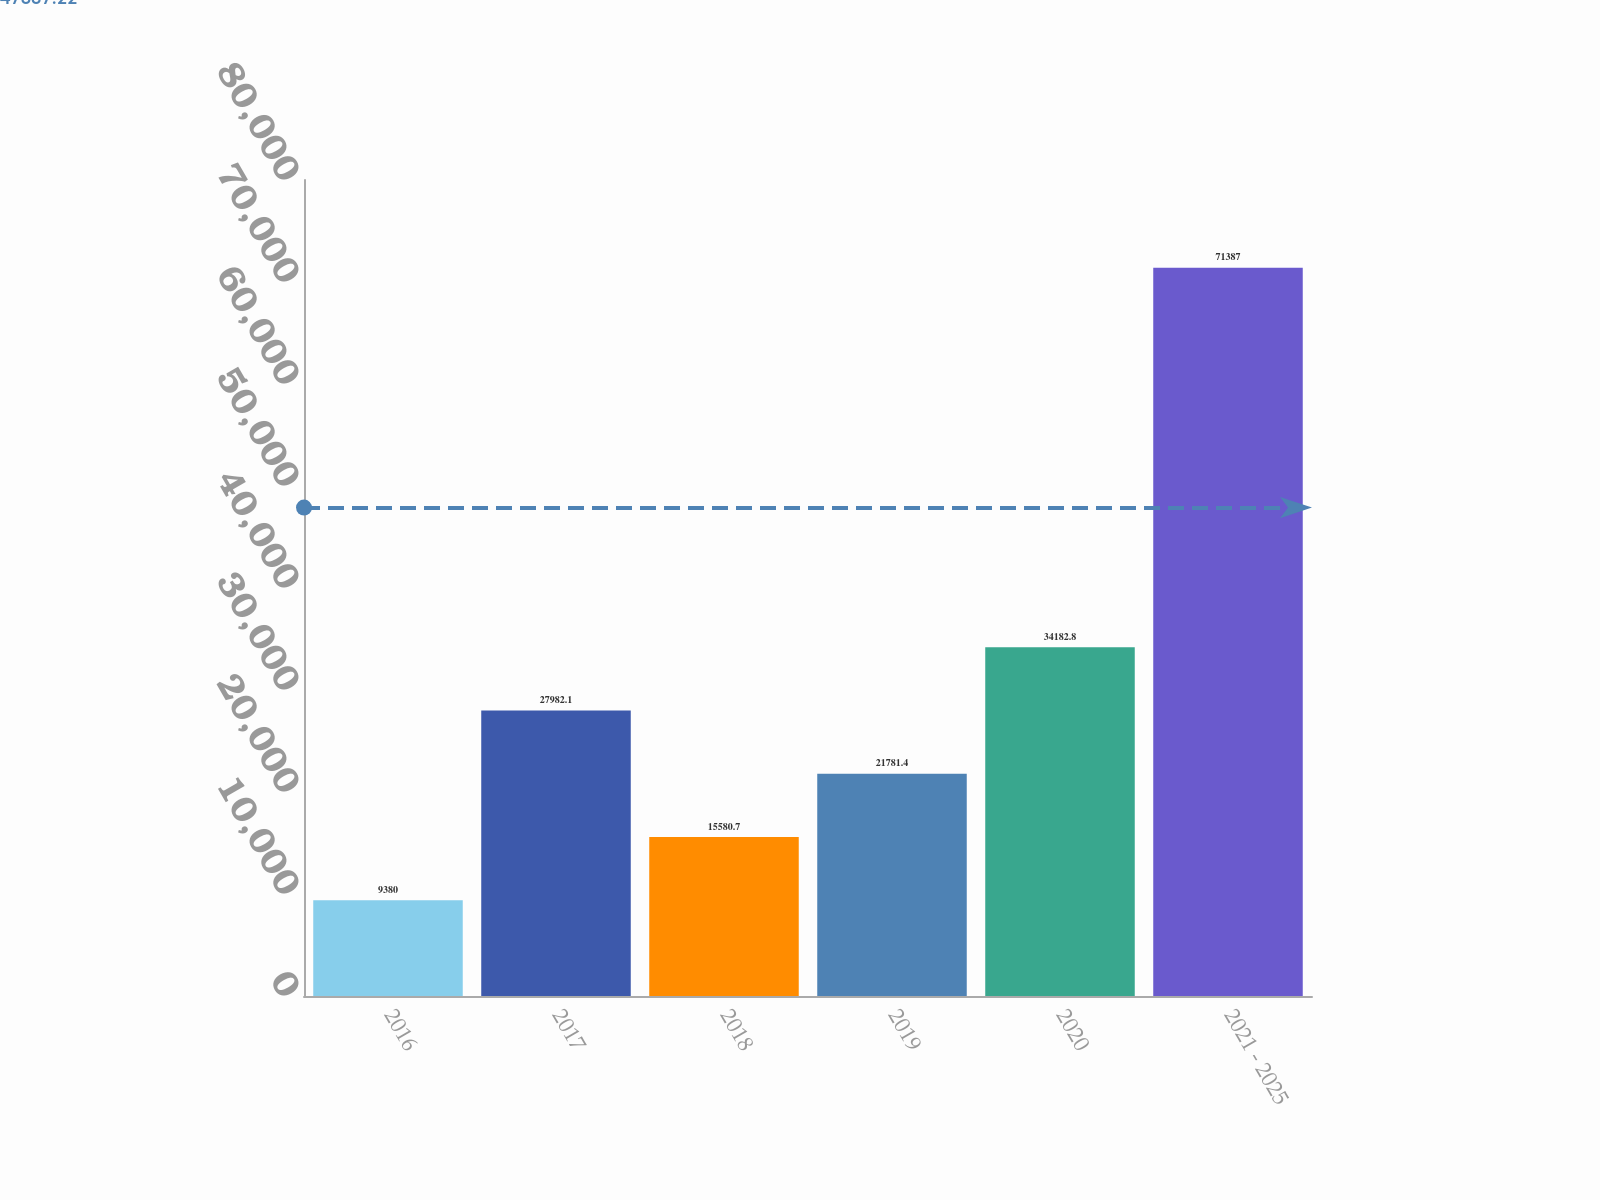Convert chart. <chart><loc_0><loc_0><loc_500><loc_500><bar_chart><fcel>2016<fcel>2017<fcel>2018<fcel>2019<fcel>2020<fcel>2021 - 2025<nl><fcel>9380<fcel>27982.1<fcel>15580.7<fcel>21781.4<fcel>34182.8<fcel>71387<nl></chart> 